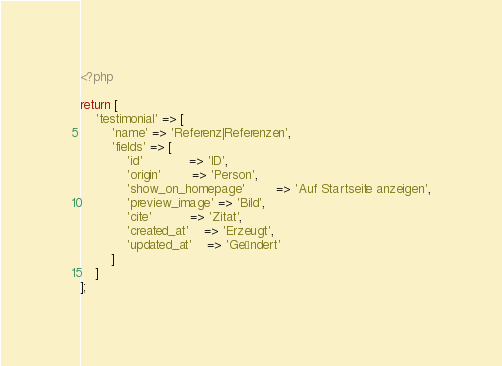Convert code to text. <code><loc_0><loc_0><loc_500><loc_500><_PHP_><?php

return [
    'testimonial' => [
        'name' => 'Referenz|Referenzen',
        'fields' => [
            'id'            => 'ID',
            'origin'        => 'Person',
            'show_on_homepage'        => 'Auf Startseite anzeigen',
            'preview_image' => 'Bild',
            'cite'          => 'Zitat',
            'created_at'    => 'Erzeugt',
            'updated_at'    => 'Geändert'
        ]
    ]
];</code> 